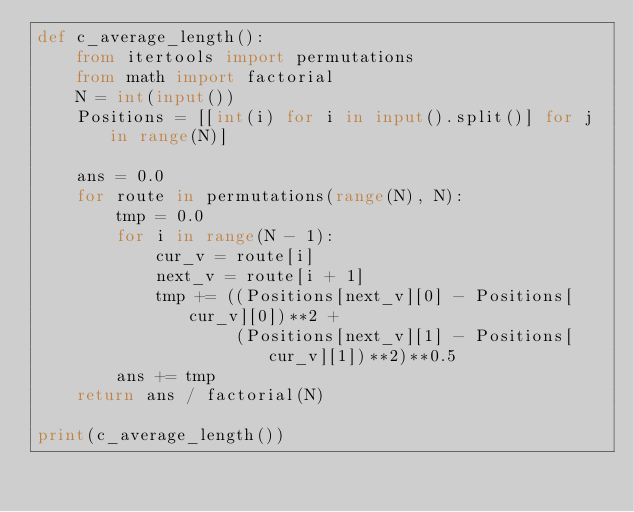<code> <loc_0><loc_0><loc_500><loc_500><_Python_>def c_average_length():
    from itertools import permutations
    from math import factorial
    N = int(input())
    Positions = [[int(i) for i in input().split()] for j in range(N)]

    ans = 0.0
    for route in permutations(range(N), N):
        tmp = 0.0
        for i in range(N - 1):
            cur_v = route[i]
            next_v = route[i + 1]
            tmp += ((Positions[next_v][0] - Positions[cur_v][0])**2 +
                    (Positions[next_v][1] - Positions[cur_v][1])**2)**0.5
        ans += tmp
    return ans / factorial(N)

print(c_average_length())</code> 